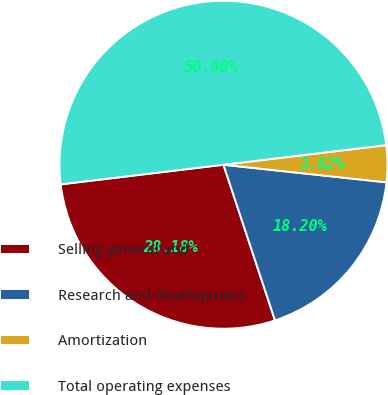Convert chart. <chart><loc_0><loc_0><loc_500><loc_500><pie_chart><fcel>Selling general and<fcel>Research and development<fcel>Amortization<fcel>Total operating expenses<nl><fcel>28.18%<fcel>18.2%<fcel>3.62%<fcel>50.0%<nl></chart> 